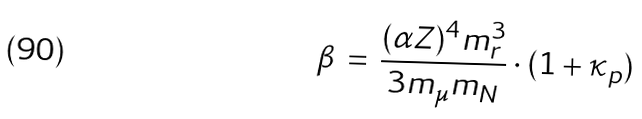Convert formula to latex. <formula><loc_0><loc_0><loc_500><loc_500>\beta \, = \, \frac { ( \alpha Z ) ^ { 4 } m _ { r } ^ { 3 } } { 3 m _ { \mu } m _ { N } } \cdot ( 1 + \kappa _ { p } )</formula> 